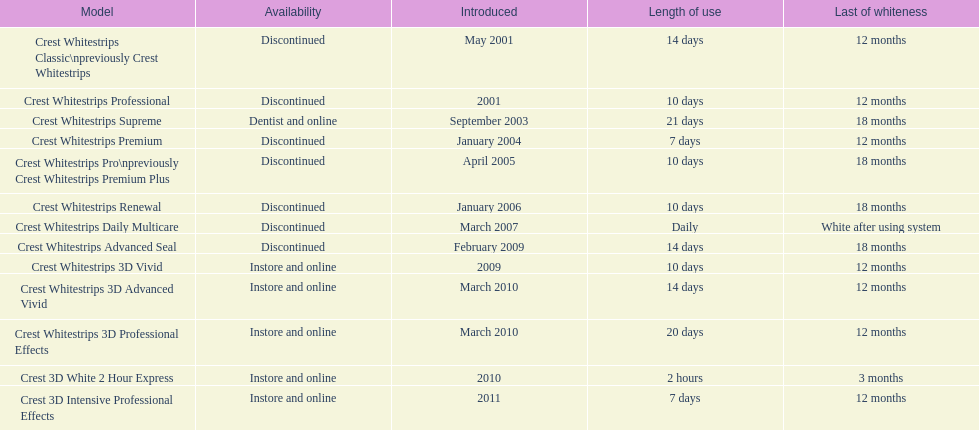Which product was to be used longer, crest whitestrips classic or crest whitestrips 3d vivid? Crest Whitestrips Classic. 